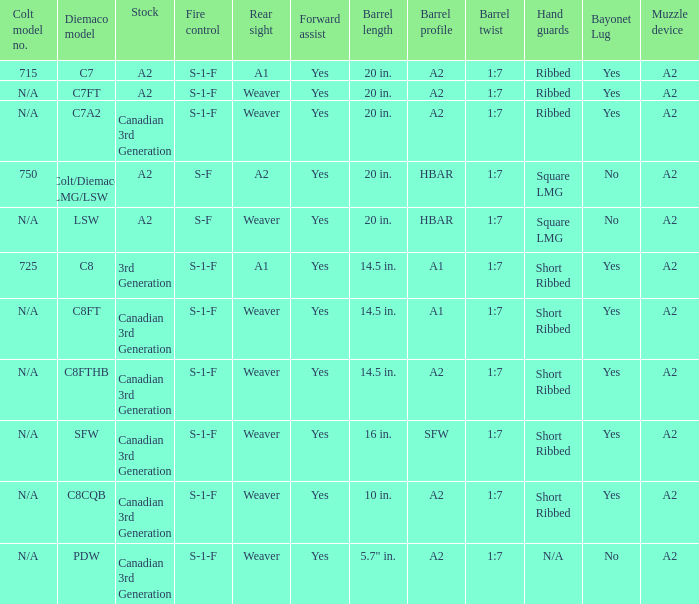Which Barrel twist has a Stock of canadian 3rd generation and a Hand guards of short ribbed? 1:7, 1:7, 1:7, 1:7. 